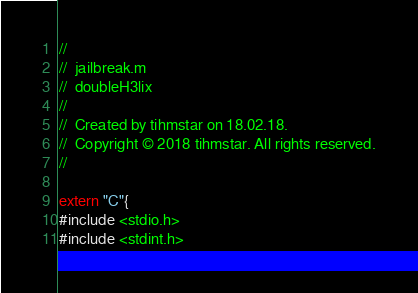Convert code to text. <code><loc_0><loc_0><loc_500><loc_500><_ObjectiveC_>//
//  jailbreak.m
//  doubleH3lix
//
//  Created by tihmstar on 18.02.18.
//  Copyright © 2018 tihmstar. All rights reserved.
//

extern "C"{
#include <stdio.h>
#include <stdint.h></code> 